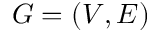<formula> <loc_0><loc_0><loc_500><loc_500>G = ( V , E )</formula> 